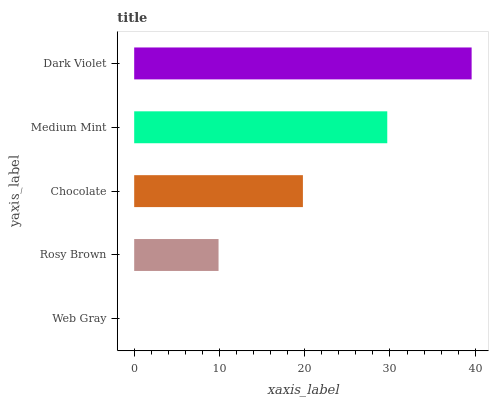Is Web Gray the minimum?
Answer yes or no. Yes. Is Dark Violet the maximum?
Answer yes or no. Yes. Is Rosy Brown the minimum?
Answer yes or no. No. Is Rosy Brown the maximum?
Answer yes or no. No. Is Rosy Brown greater than Web Gray?
Answer yes or no. Yes. Is Web Gray less than Rosy Brown?
Answer yes or no. Yes. Is Web Gray greater than Rosy Brown?
Answer yes or no. No. Is Rosy Brown less than Web Gray?
Answer yes or no. No. Is Chocolate the high median?
Answer yes or no. Yes. Is Chocolate the low median?
Answer yes or no. Yes. Is Dark Violet the high median?
Answer yes or no. No. Is Web Gray the low median?
Answer yes or no. No. 